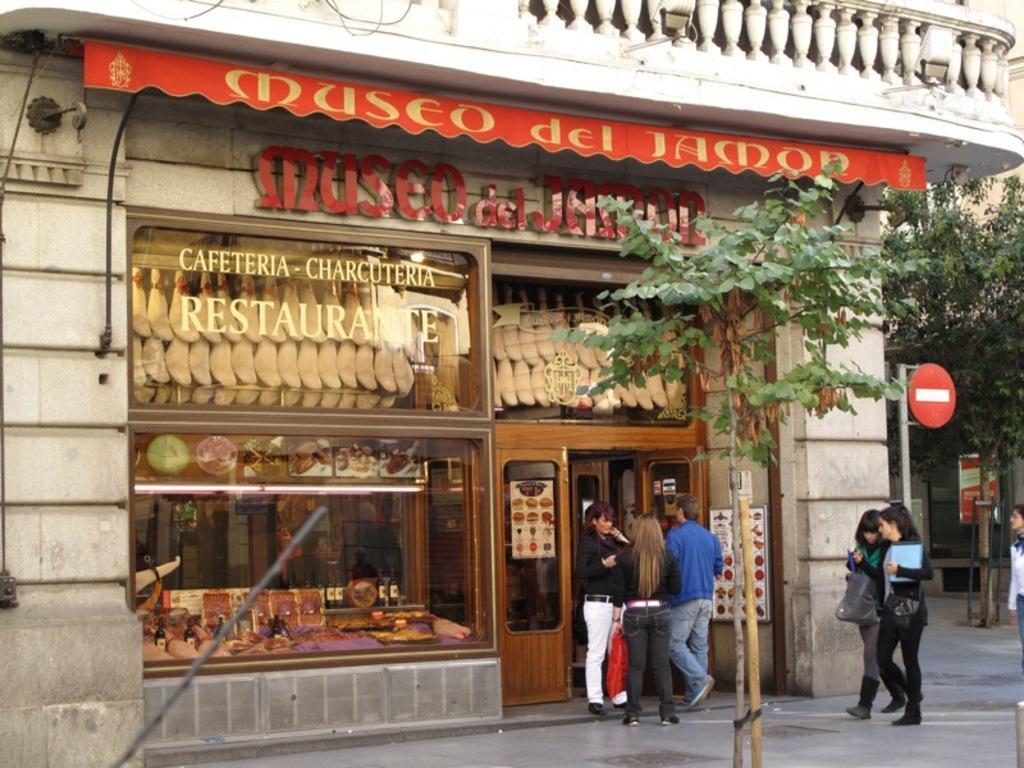Can you describe this image briefly? Here in this picture we can see a store present over a place and we can see some people standing and walking on the road in front of it over there and we can also see sign board present on pole and we can see a plant present in the front and we can also see other trees also present over there. 